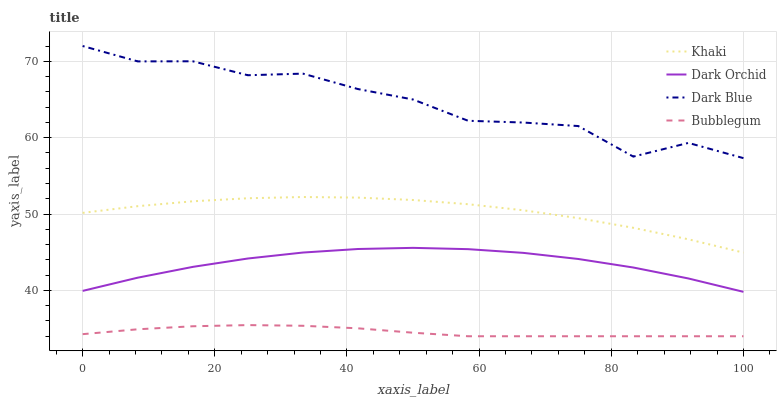Does Bubblegum have the minimum area under the curve?
Answer yes or no. Yes. Does Dark Blue have the maximum area under the curve?
Answer yes or no. Yes. Does Khaki have the minimum area under the curve?
Answer yes or no. No. Does Khaki have the maximum area under the curve?
Answer yes or no. No. Is Bubblegum the smoothest?
Answer yes or no. Yes. Is Dark Blue the roughest?
Answer yes or no. Yes. Is Khaki the smoothest?
Answer yes or no. No. Is Khaki the roughest?
Answer yes or no. No. Does Khaki have the lowest value?
Answer yes or no. No. Does Dark Blue have the highest value?
Answer yes or no. Yes. Does Khaki have the highest value?
Answer yes or no. No. Is Bubblegum less than Dark Blue?
Answer yes or no. Yes. Is Dark Blue greater than Khaki?
Answer yes or no. Yes. Does Bubblegum intersect Dark Blue?
Answer yes or no. No. 